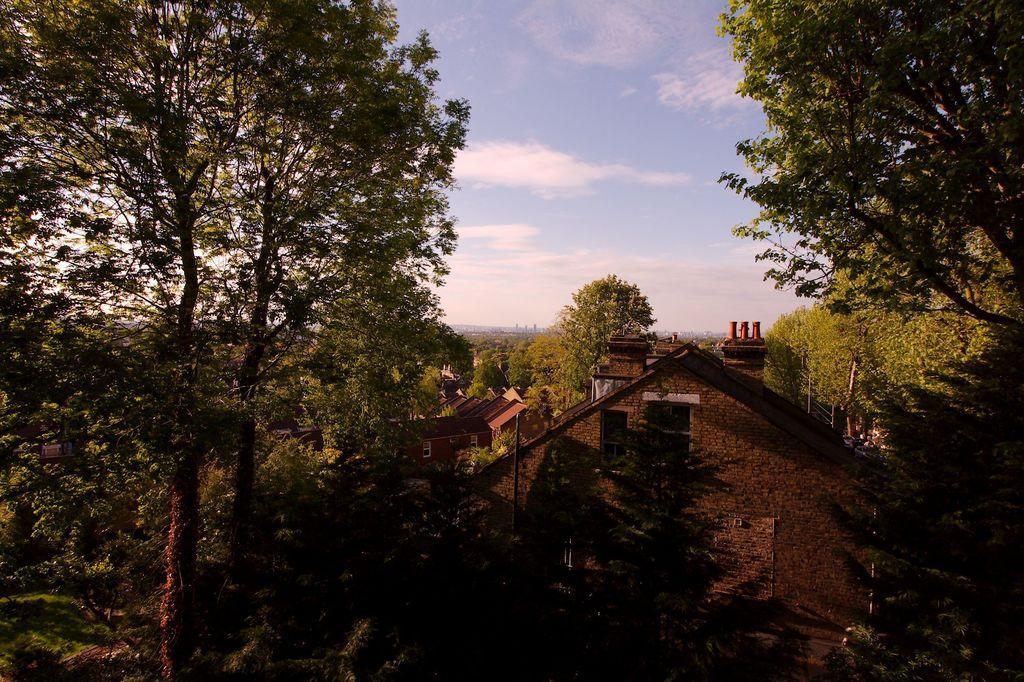Please provide a concise description of this image. In this image at the bottom three are houses. In the middle there are trees, sky and clouds. 